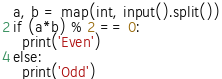<code> <loc_0><loc_0><loc_500><loc_500><_Python_>a, b = map(int, input().split())
if (a*b) % 2 == 0:
  print('Even')
else:
  print('Odd')</code> 